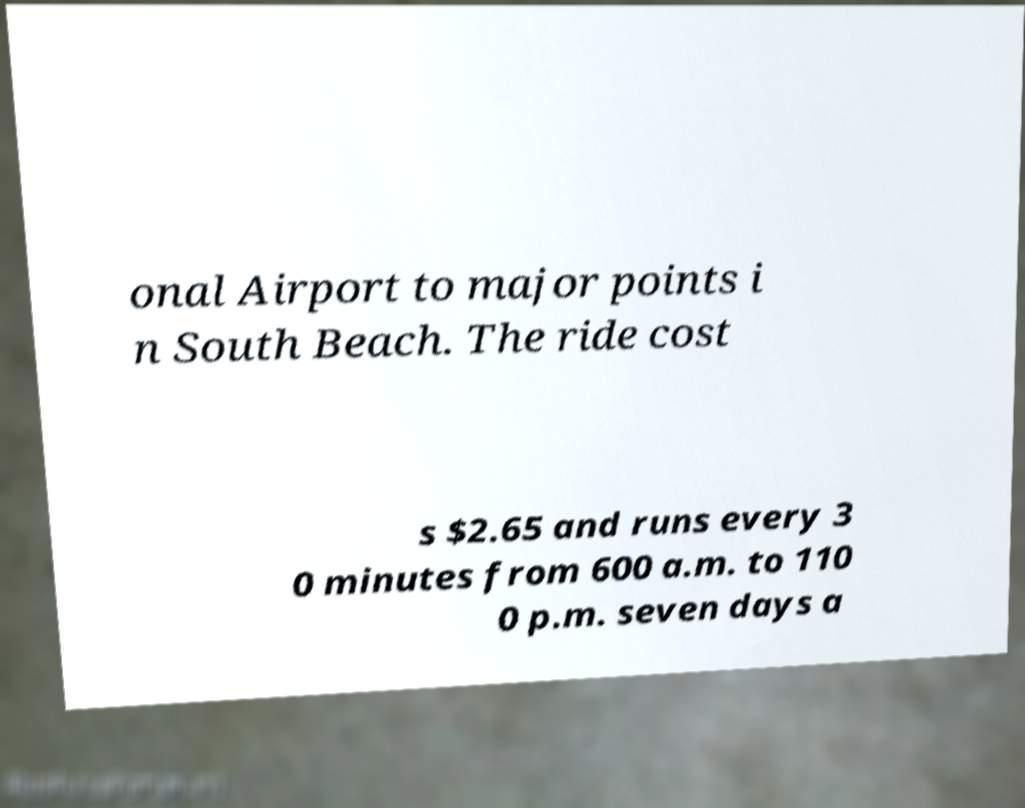Please identify and transcribe the text found in this image. onal Airport to major points i n South Beach. The ride cost s $2.65 and runs every 3 0 minutes from 600 a.m. to 110 0 p.m. seven days a 